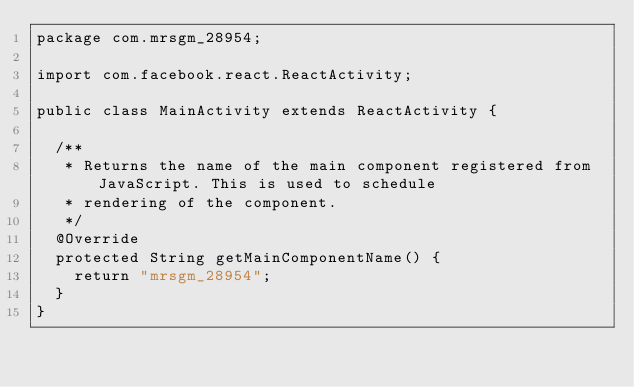Convert code to text. <code><loc_0><loc_0><loc_500><loc_500><_Java_>package com.mrsgm_28954;

import com.facebook.react.ReactActivity;

public class MainActivity extends ReactActivity {

  /**
   * Returns the name of the main component registered from JavaScript. This is used to schedule
   * rendering of the component.
   */
  @Override
  protected String getMainComponentName() {
    return "mrsgm_28954";
  }
}
</code> 